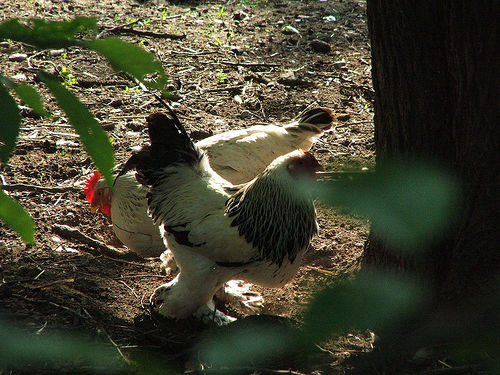<image>
Is the hen on the tree? No. The hen is not positioned on the tree. They may be near each other, but the hen is not supported by or resting on top of the tree. 